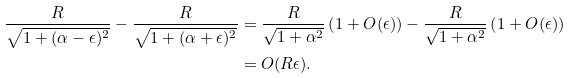<formula> <loc_0><loc_0><loc_500><loc_500>\frac { R } { \sqrt { 1 + ( \alpha - \epsilon ) ^ { 2 } } } - \frac { R } { \sqrt { 1 + ( \alpha + \epsilon ) ^ { 2 } } } & = \frac { R } { \sqrt { 1 + \alpha ^ { 2 } } } \left ( 1 + O ( \epsilon ) \right ) - \frac { R } { \sqrt { 1 + \alpha ^ { 2 } } } \left ( 1 + O ( \epsilon ) \right ) \\ & = O ( R \epsilon ) .</formula> 